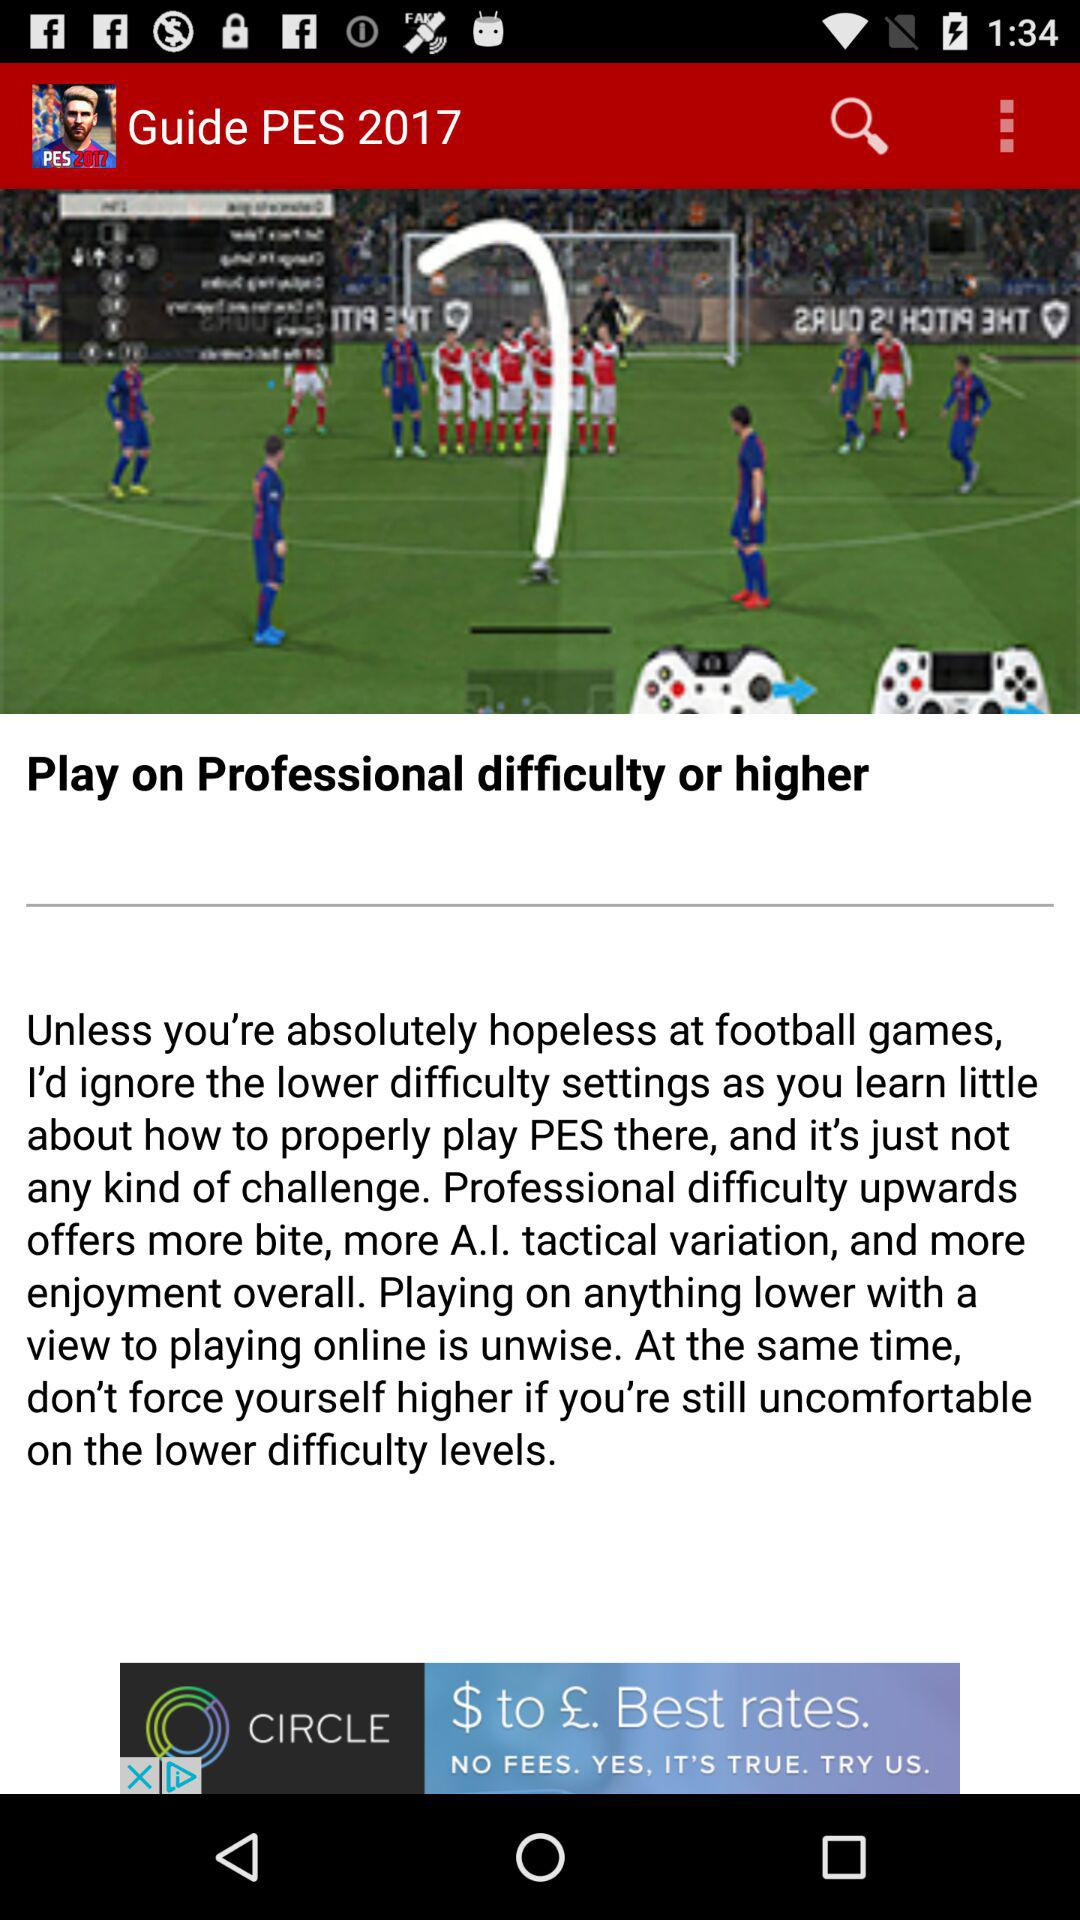What is the game name? The game name is "PES". 